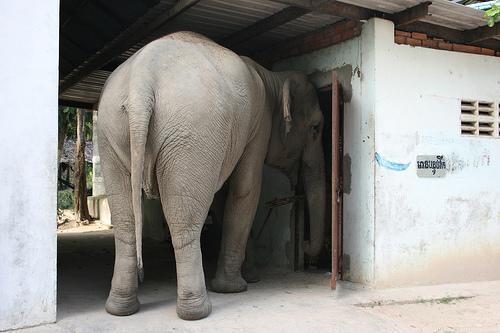How many legs does the elephant have?
Give a very brief answer. 4. 